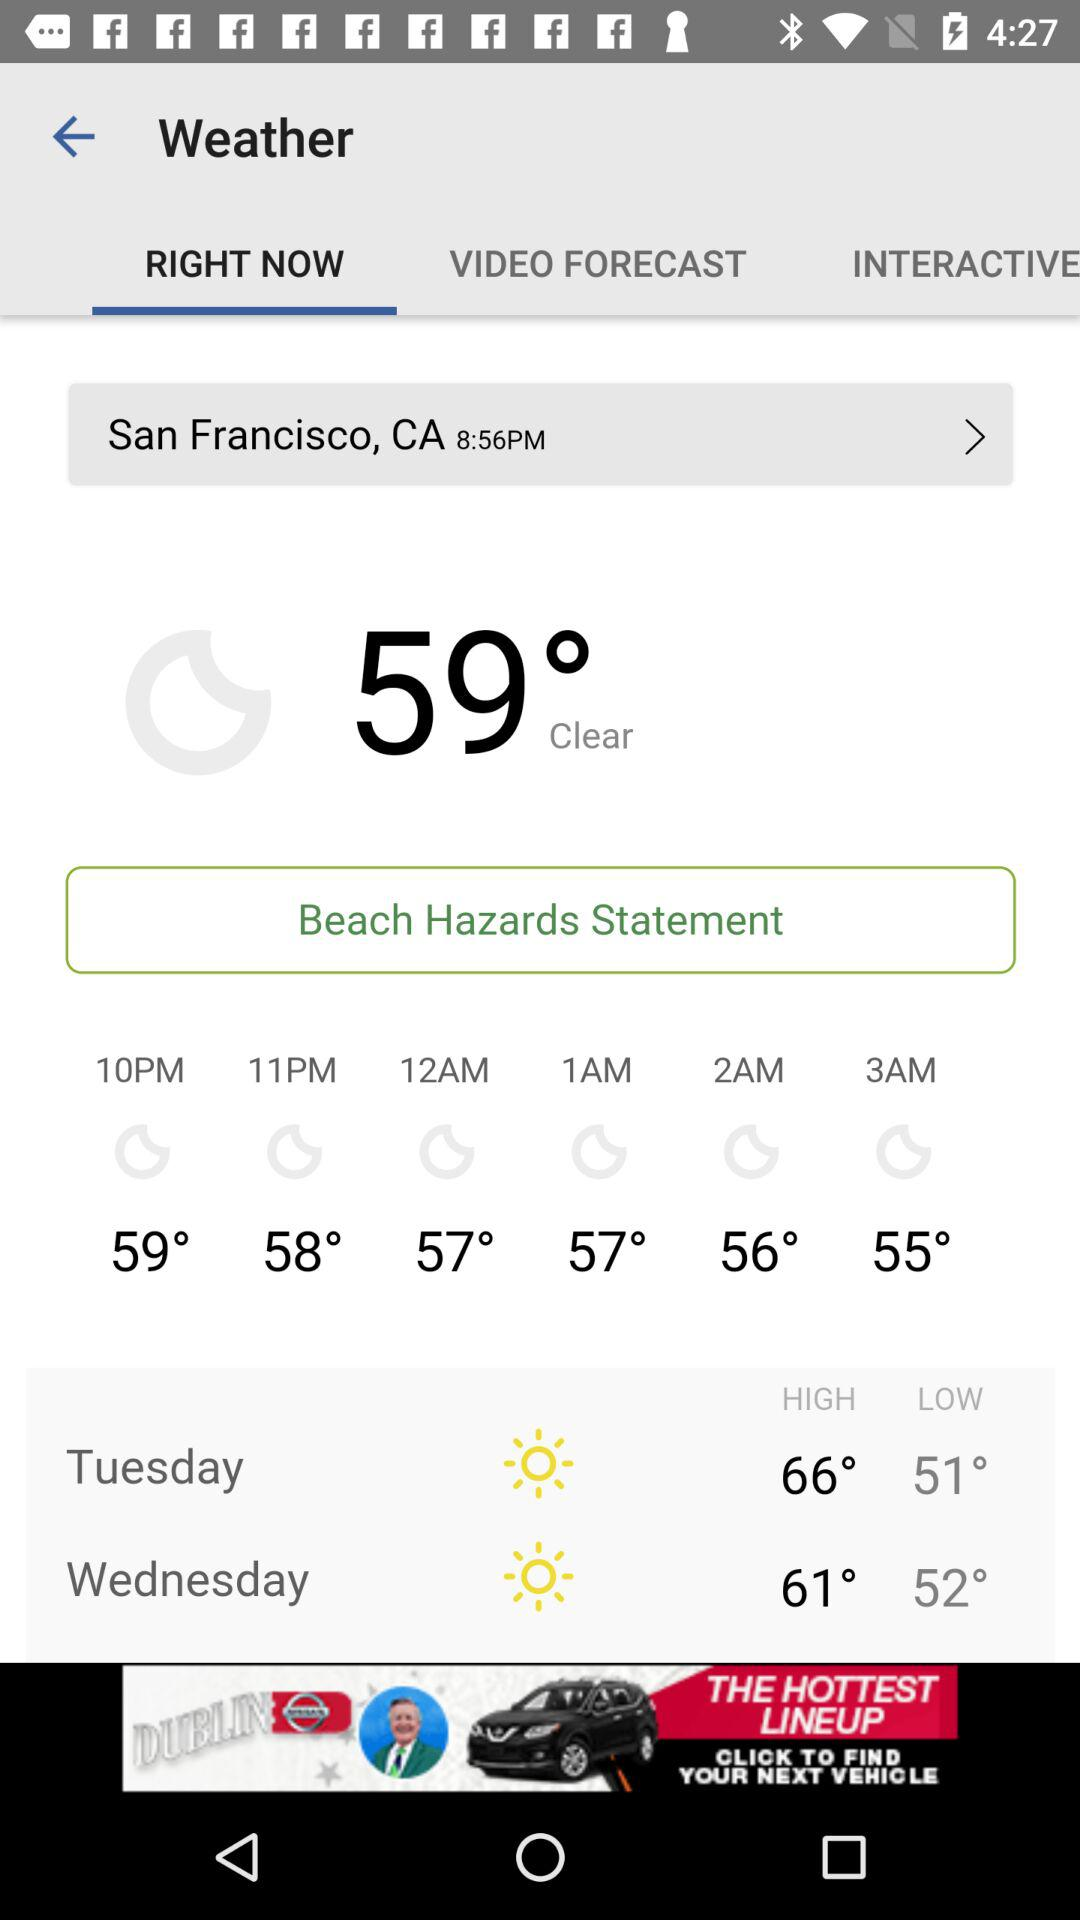How many degrees Fahrenheit is the difference between the high and low temperatures for Wednesday?
Answer the question using a single word or phrase. 9 